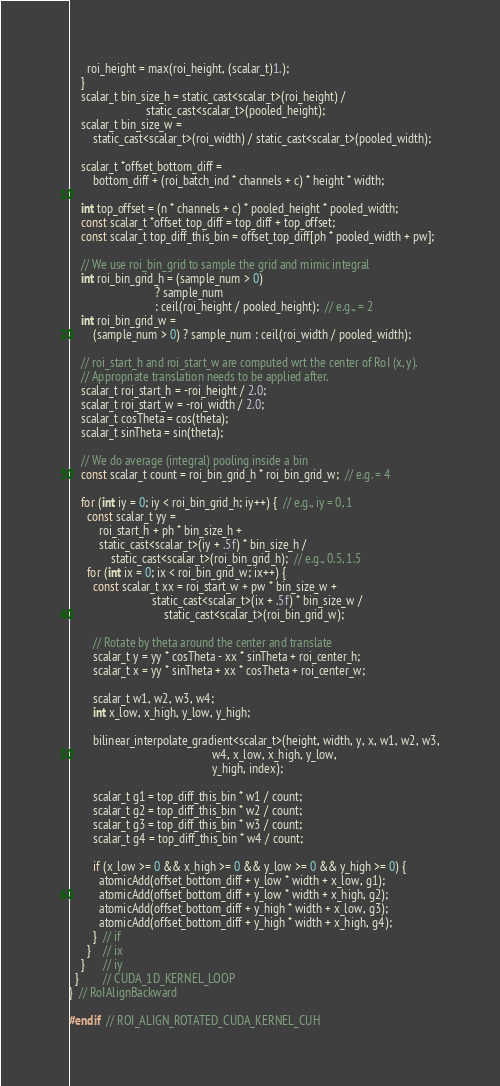Convert code to text. <code><loc_0><loc_0><loc_500><loc_500><_Cuda_>      roi_height = max(roi_height, (scalar_t)1.);
    }
    scalar_t bin_size_h = static_cast<scalar_t>(roi_height) /
                          static_cast<scalar_t>(pooled_height);
    scalar_t bin_size_w =
        static_cast<scalar_t>(roi_width) / static_cast<scalar_t>(pooled_width);

    scalar_t *offset_bottom_diff =
        bottom_diff + (roi_batch_ind * channels + c) * height * width;

    int top_offset = (n * channels + c) * pooled_height * pooled_width;
    const scalar_t *offset_top_diff = top_diff + top_offset;
    const scalar_t top_diff_this_bin = offset_top_diff[ph * pooled_width + pw];

    // We use roi_bin_grid to sample the grid and mimic integral
    int roi_bin_grid_h = (sample_num > 0)
                             ? sample_num
                             : ceil(roi_height / pooled_height);  // e.g., = 2
    int roi_bin_grid_w =
        (sample_num > 0) ? sample_num : ceil(roi_width / pooled_width);

    // roi_start_h and roi_start_w are computed wrt the center of RoI (x, y).
    // Appropriate translation needs to be applied after.
    scalar_t roi_start_h = -roi_height / 2.0;
    scalar_t roi_start_w = -roi_width / 2.0;
    scalar_t cosTheta = cos(theta);
    scalar_t sinTheta = sin(theta);

    // We do average (integral) pooling inside a bin
    const scalar_t count = roi_bin_grid_h * roi_bin_grid_w;  // e.g. = 4

    for (int iy = 0; iy < roi_bin_grid_h; iy++) {  // e.g., iy = 0, 1
      const scalar_t yy =
          roi_start_h + ph * bin_size_h +
          static_cast<scalar_t>(iy + .5f) * bin_size_h /
              static_cast<scalar_t>(roi_bin_grid_h);  // e.g., 0.5, 1.5
      for (int ix = 0; ix < roi_bin_grid_w; ix++) {
        const scalar_t xx = roi_start_w + pw * bin_size_w +
                            static_cast<scalar_t>(ix + .5f) * bin_size_w /
                                static_cast<scalar_t>(roi_bin_grid_w);

        // Rotate by theta around the center and translate
        scalar_t y = yy * cosTheta - xx * sinTheta + roi_center_h;
        scalar_t x = yy * sinTheta + xx * cosTheta + roi_center_w;

        scalar_t w1, w2, w3, w4;
        int x_low, x_high, y_low, y_high;

        bilinear_interpolate_gradient<scalar_t>(height, width, y, x, w1, w2, w3,
                                                w4, x_low, x_high, y_low,
                                                y_high, index);

        scalar_t g1 = top_diff_this_bin * w1 / count;
        scalar_t g2 = top_diff_this_bin * w2 / count;
        scalar_t g3 = top_diff_this_bin * w3 / count;
        scalar_t g4 = top_diff_this_bin * w4 / count;

        if (x_low >= 0 && x_high >= 0 && y_low >= 0 && y_high >= 0) {
          atomicAdd(offset_bottom_diff + y_low * width + x_low, g1);
          atomicAdd(offset_bottom_diff + y_low * width + x_high, g2);
          atomicAdd(offset_bottom_diff + y_high * width + x_low, g3);
          atomicAdd(offset_bottom_diff + y_high * width + x_high, g4);
        }  // if
      }    // ix
    }      // iy
  }        // CUDA_1D_KERNEL_LOOP
}  // RoIAlignBackward

#endif  // ROI_ALIGN_ROTATED_CUDA_KERNEL_CUH
</code> 